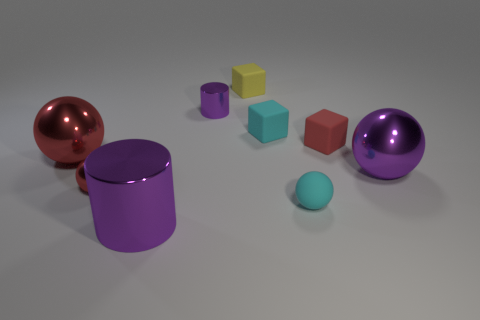Could you describe the lighting and the possible source within this image? The lighting in the image is soft and diffuse, providing an even illumination across the scene. There are no harsh shadows or strong highlights to suggest a direct light source, implying the lighting may be from overhead softboxes or a simulation of natural light from multiple angles, as typically arranged in a studio setting. 